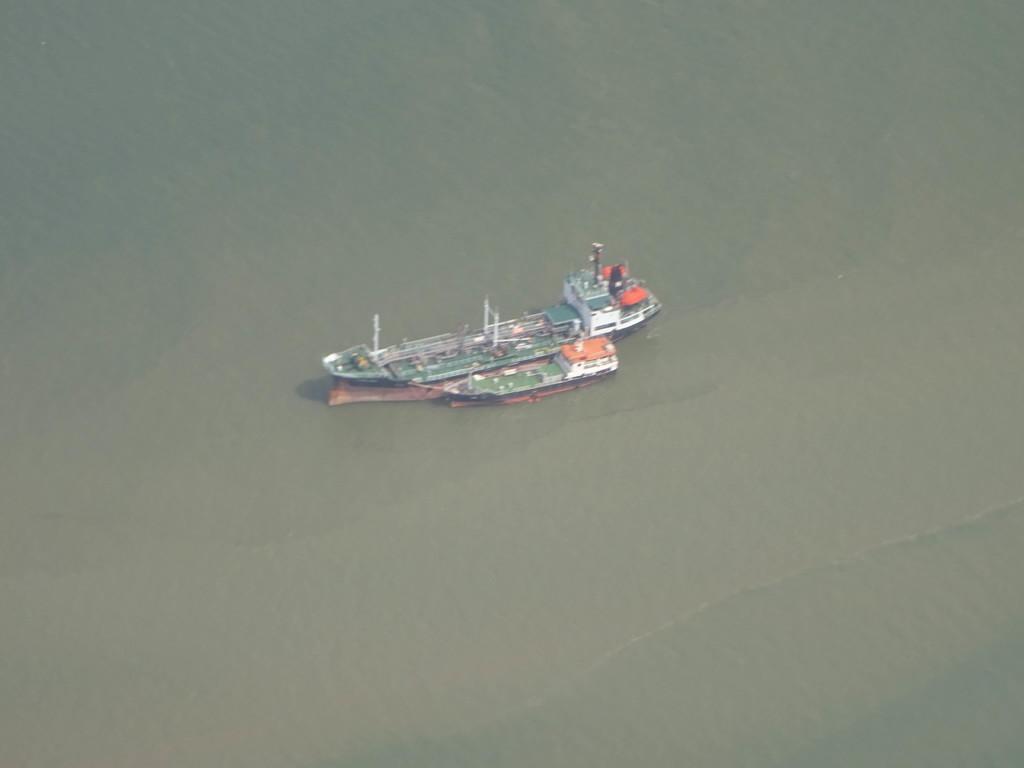How would you summarize this image in a sentence or two? In the center of the image we can see a boat on the water. 